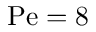Convert formula to latex. <formula><loc_0><loc_0><loc_500><loc_500>P e = 8</formula> 